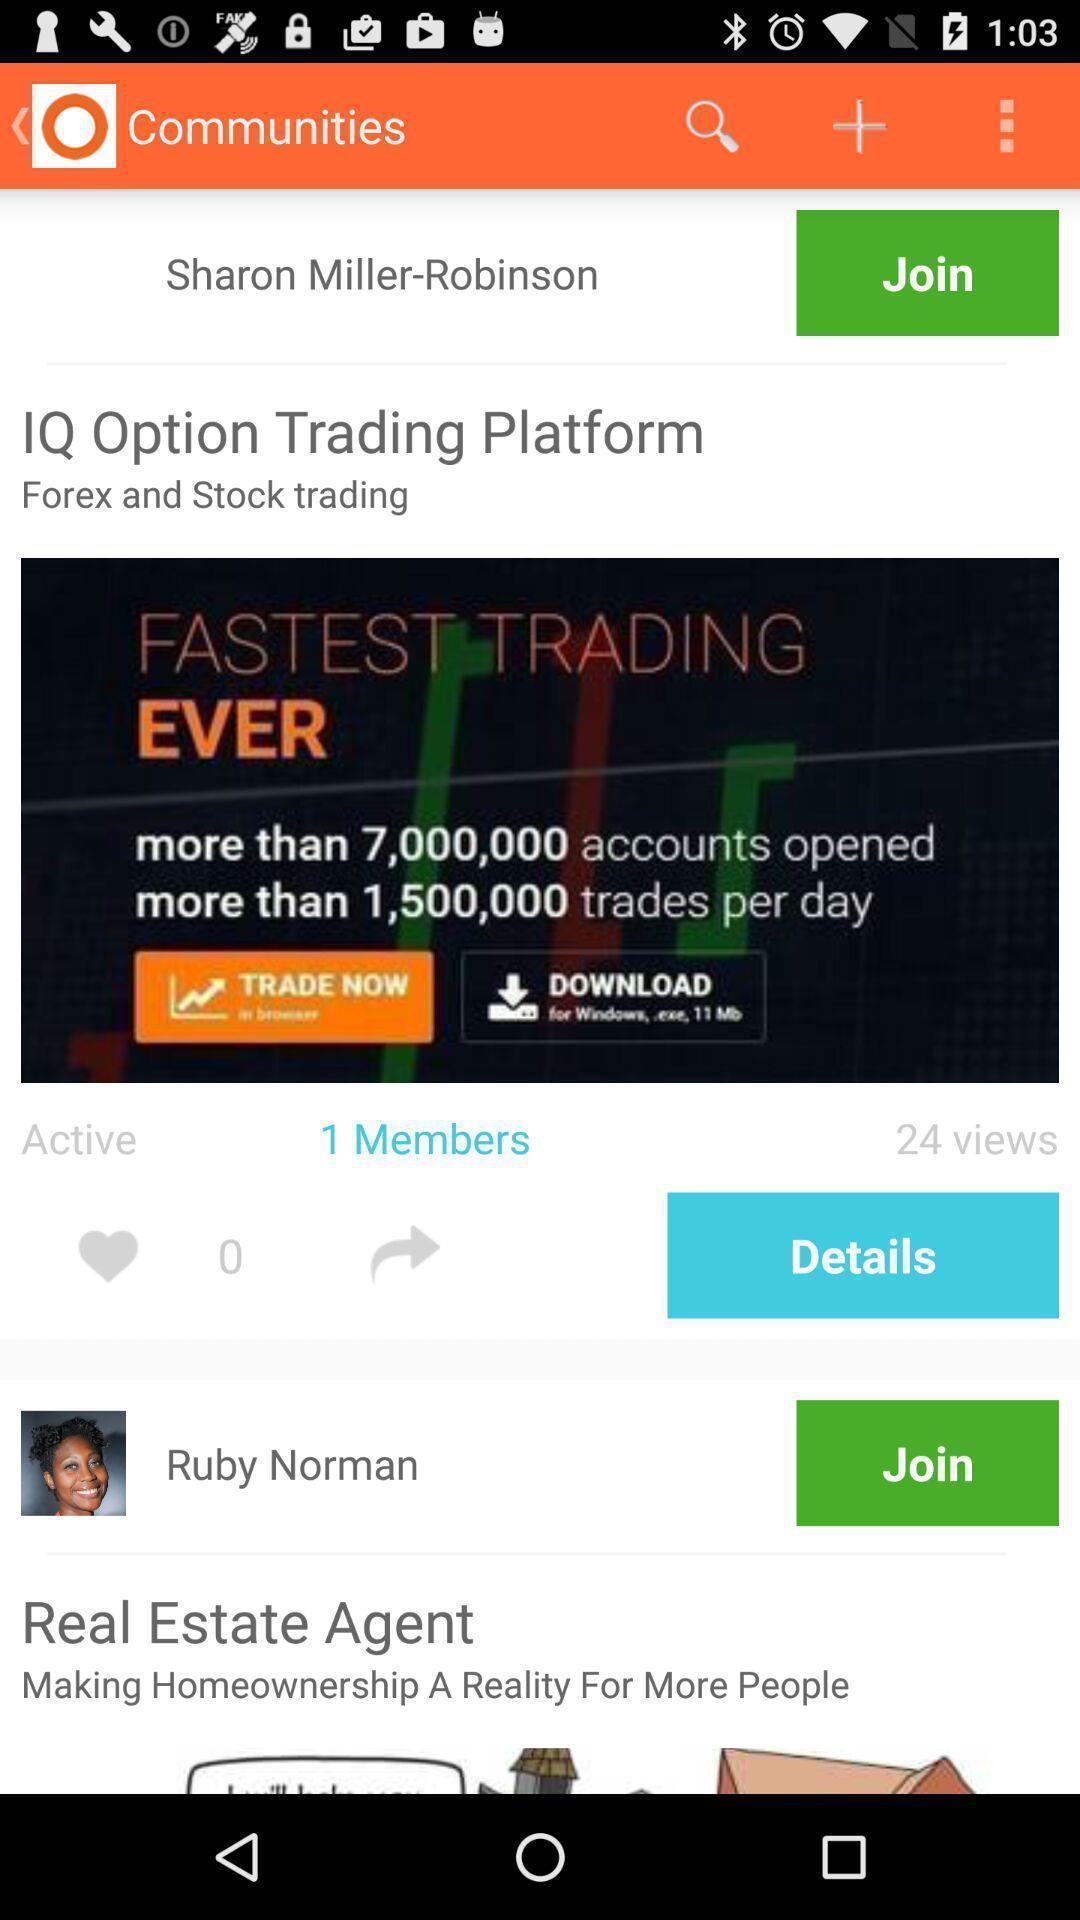Give me a narrative description of this picture. Screen displaying the search bar to find communities. 